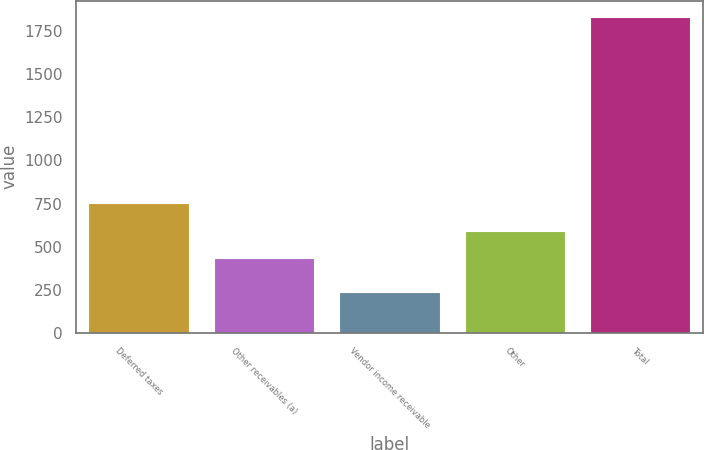<chart> <loc_0><loc_0><loc_500><loc_500><bar_chart><fcel>Deferred taxes<fcel>Other receivables (a)<fcel>Vendor income receivable<fcel>Other<fcel>Total<nl><fcel>752.8<fcel>433<fcel>236<fcel>592.9<fcel>1835<nl></chart> 